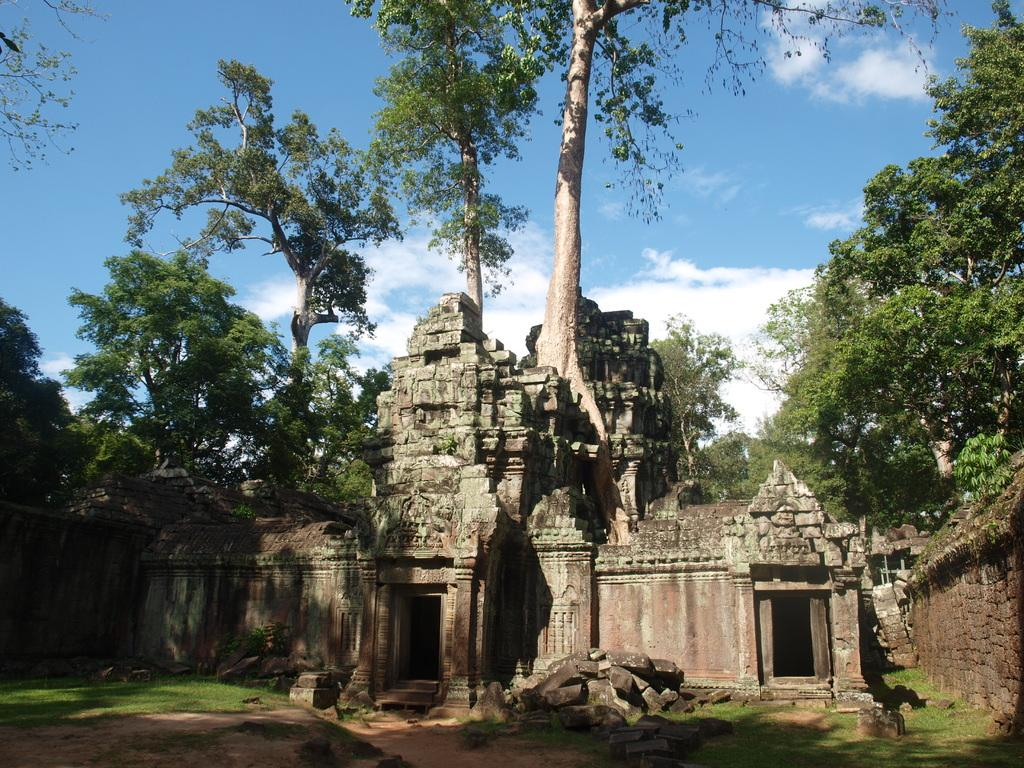What is the main structure in the image? There is a monument in the image. What type of vegetation is present in the image? There are trees in the image. What covers the ground in the image? There is grass on the ground in the image. How would you describe the sky in the image? The sky is blue and cloudy in the image. How does the monument contribute to the profit of the city in the image? The image does not provide information about the monument's contribution to the city's profit. 